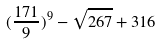<formula> <loc_0><loc_0><loc_500><loc_500>( \frac { 1 7 1 } { 9 } ) ^ { 9 } - \sqrt { 2 6 7 } + 3 1 6</formula> 